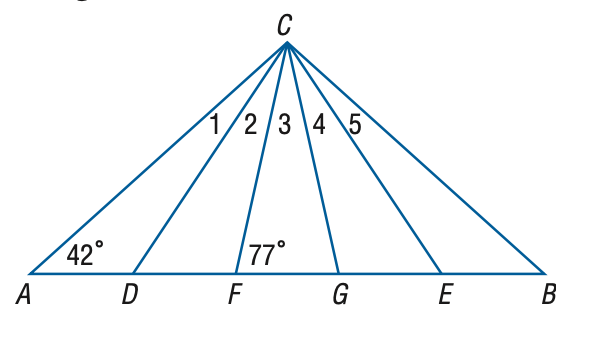Answer the mathemtical geometry problem and directly provide the correct option letter.
Question: In the figure, \triangle A B C is isosceles, \triangle D C E is equilateral, and \triangle F C G is isosceles. Find the measure of the \angle 2 at vertex C.
Choices: A: 14 B: 16 C: 17 D: 18 C 